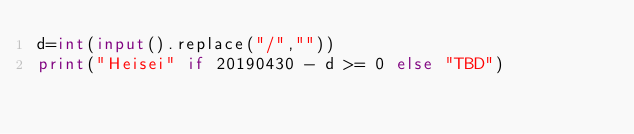<code> <loc_0><loc_0><loc_500><loc_500><_Python_>d=int(input().replace("/",""))
print("Heisei" if 20190430 - d >= 0 else "TBD")</code> 